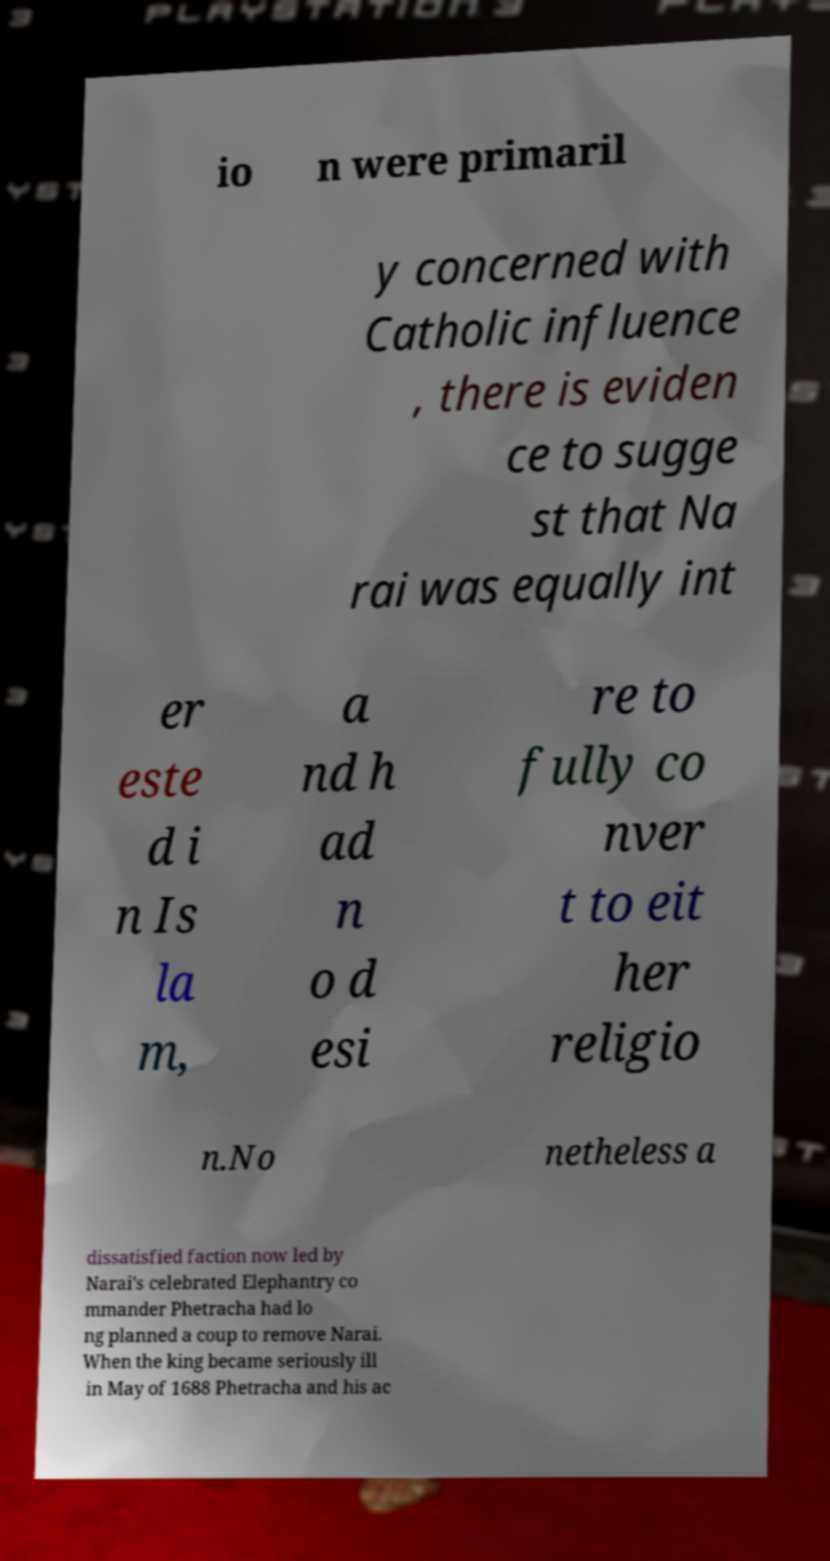Can you read and provide the text displayed in the image?This photo seems to have some interesting text. Can you extract and type it out for me? io n were primaril y concerned with Catholic influence , there is eviden ce to sugge st that Na rai was equally int er este d i n Is la m, a nd h ad n o d esi re to fully co nver t to eit her religio n.No netheless a dissatisfied faction now led by Narai's celebrated Elephantry co mmander Phetracha had lo ng planned a coup to remove Narai. When the king became seriously ill in May of 1688 Phetracha and his ac 